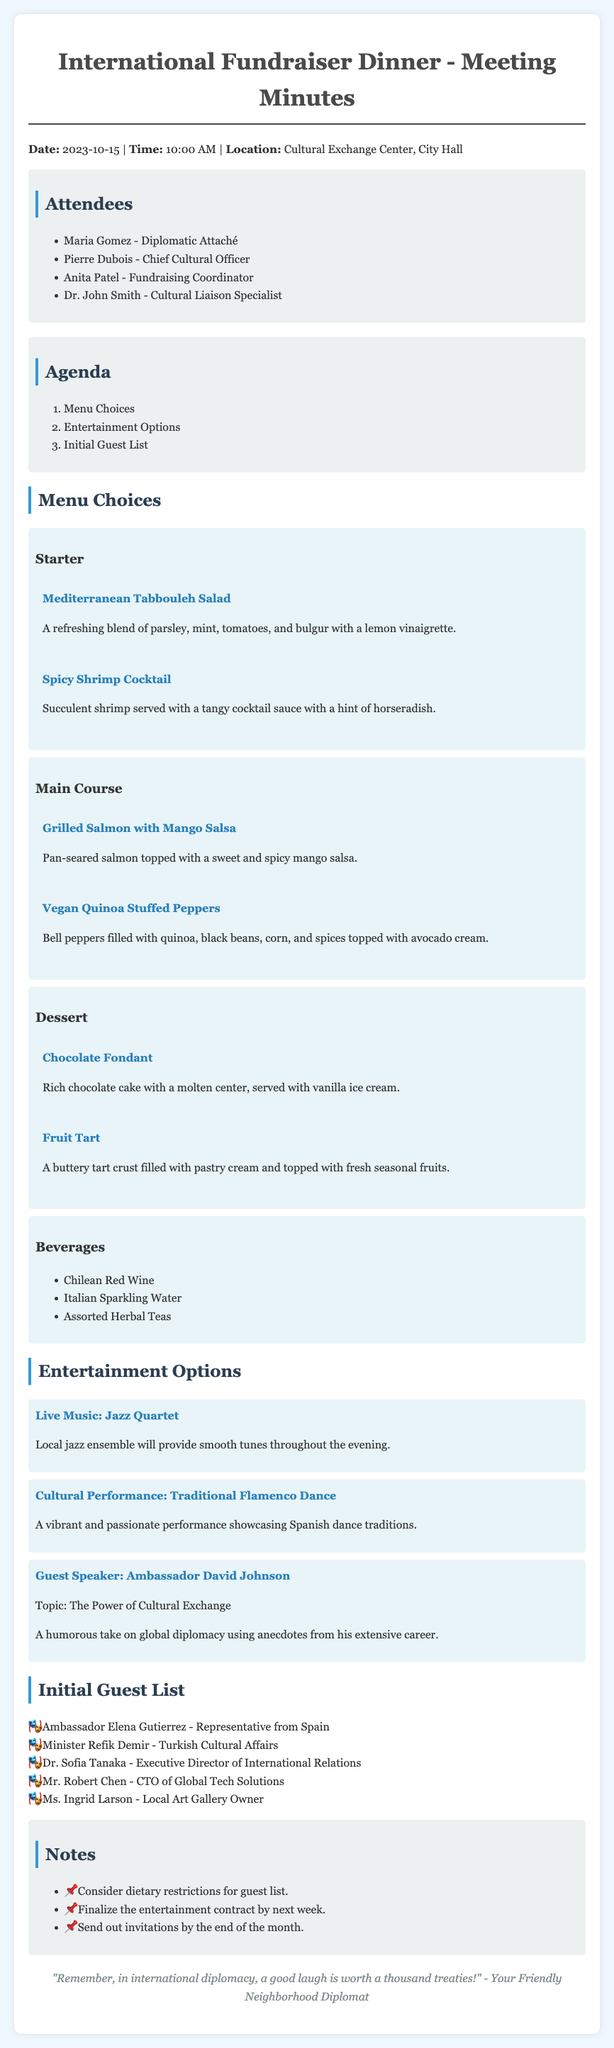What is the date of the meeting? The date of the meeting is stated as 2023-10-15 in the document.
Answer: 2023-10-15 Who is the Chief Cultural Officer? The name of the Chief Cultural Officer is listed among the attendees as Pierre Dubois.
Answer: Pierre Dubois What are the beverage options mentioned? The beverages listed in the document include Chilean Red Wine, Italian Sparkling Water, and Assorted Herbal Teas.
Answer: Chilean Red Wine, Italian Sparkling Water, Assorted Herbal Teas How many menu choices are included in the document? The document provides three main menu sections: Starter, Main Course, and Dessert, which sums up to nine distinct menu items.
Answer: Nine What type of dessert is mentioned first? The dessert is categorized first in the menu choices, where Chocolate Fondant is listed.
Answer: Chocolate Fondant What is the topic of the guest speaker? The guest speaker's topic is provided in the document and discusses "The Power of Cultural Exchange."
Answer: The Power of Cultural Exchange What is the main purpose of the meeting? The agenda demonstrates that the main purpose is to decide on menu choices, entertainment options, and the initial guest list for the fundraiser dinner.
Answer: Fundraiser dinner Who is the local guest performing at the event? The document lists a cultural performance showcasing Spanish dance traditions, indicating that the local guests are part of the entertainment options presented.
Answer: Cultural Performance: Traditional Flamenco Dance 